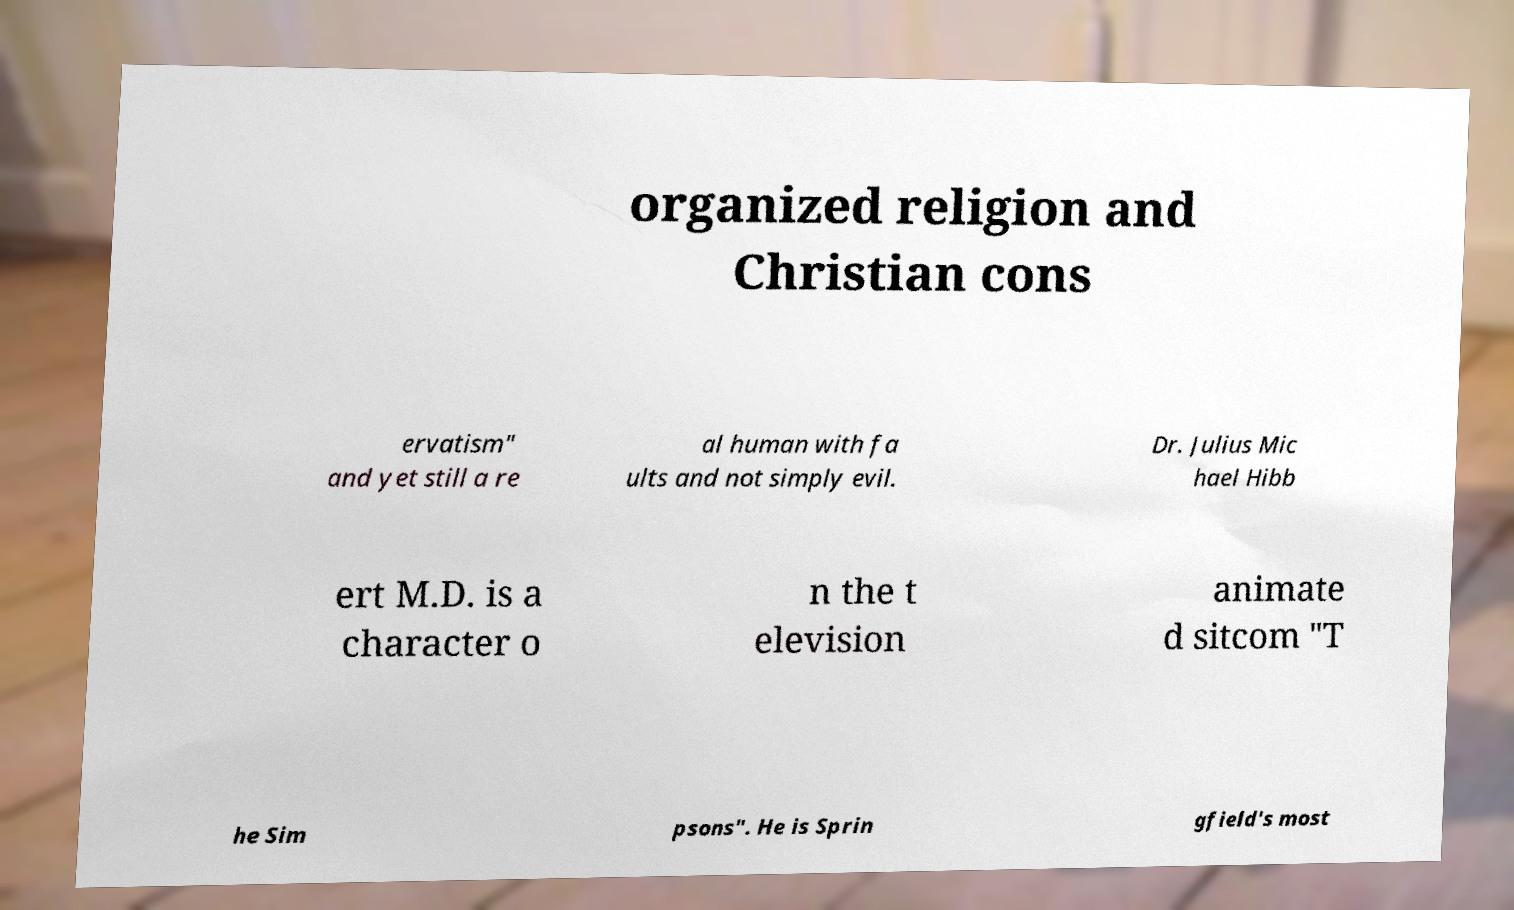Could you assist in decoding the text presented in this image and type it out clearly? organized religion and Christian cons ervatism" and yet still a re al human with fa ults and not simply evil. Dr. Julius Mic hael Hibb ert M.D. is a character o n the t elevision animate d sitcom "T he Sim psons". He is Sprin gfield's most 